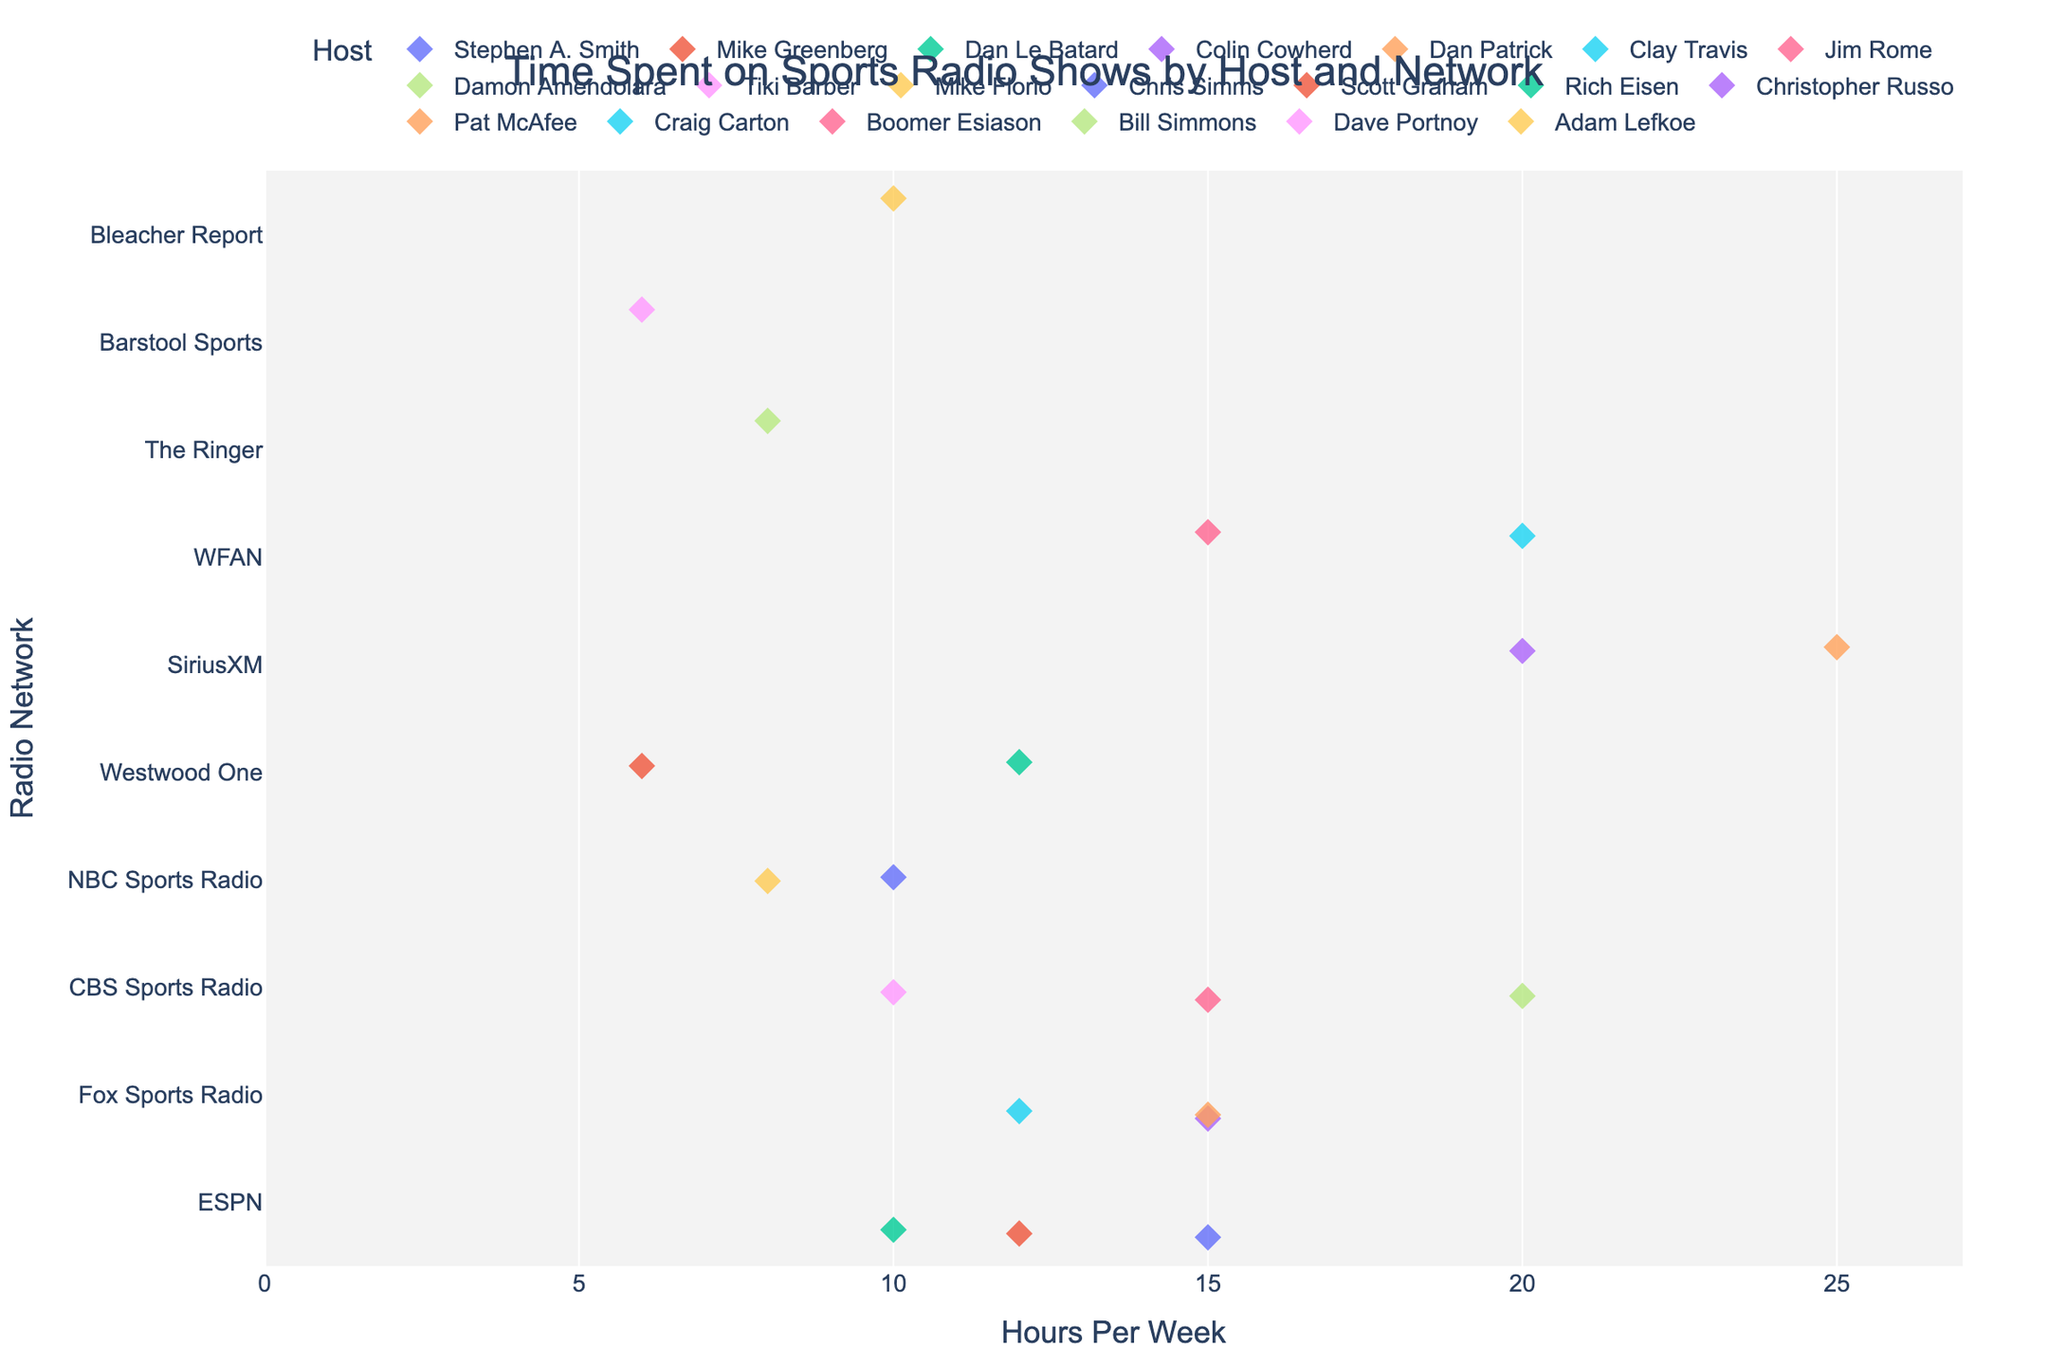What's the total number of hosts from ESPN? Look at the hosts listed under the ESPN network. There are three hosts: Stephen A. Smith, Mike Greenberg, and Dan Le Batard.
Answer: 3 Which hosts spend the most time on sports radio shows across all networks? Identify the hosts with the highest "Hours Per Week" values. Both Pat McAfee from SiriusXM and Damon Amendolara from CBS Sports Radio spend 25 hours each week, the highest among all hosts.
Answer: Pat McAfee, Damon Amendolara How many hours does Fox Sports Radio's Colin Cowherd spend compared to ESPN's Stephen A. Smith? Both Colin Cowherd and Stephen A. Smith spend 15 hours per week on their radio shows.
Answer: Equal What is the median duration of hosts' hours per week across all networks? List the "Hours Per Week" values in ascending order: 6, 6, 8, 8, 10, 10, 10, 10, 12, 12, 12, 15, 15, 15, 15, 15, 20, 20, 20, 25. The median is the middle value(s) in this ordered list. There are 20 data points, so the median is the average of the 10th and 11th values: (12 + 12) / 2 = 12.
Answer: 12 Which network has the greatest variability in hours spent by its hosts? Look at the range of "Hours Per Week" for each network. WFAN hosts have a range from 15 to 20 hours, whereas NBC hosts range from 8 to 10 hours. ESPN hosts range from 10 to 15 hours, and Fox Sports Radio hosts all spend between 12 and 15 hours. CBS Sports Radio has a range from 10 to 20 hours, suggesting highest variability. SiriusXM ranges from 20 to 25 hours. Barstool Sports and Westwood One have single values. CBS Sports Radio shows the greatest range.
Answer: CBS Sports Radio Which network has the highest average hours per week across its hosts? Calculate the average for each network. For instance, for Fox Sports Radio: (15+15+12)/3 = 14 hours. Repeat for all networks:
- ESPN: (15+12+10)/3 = 12.33
- Fox Sports Radio: 14
- CBS Sports Radio: (15+20+10)/3 = 15
- NBC Sports Radio: (8+10)/2 = 9
- Westwood One: (6+12)/2 = 9
- SiriusXM: (20+25)/2 = 22.5
- WFAN: (20+15)/2 = 17.5
- The Ringer: 8
- Barstool Sports: 6
- Bleacher Report: 10
SiriusXM has the highest average.
Answer: SiriusXM Between CBS Sports Radio and WFAN, which network has hosts spending a total of 55 hours per week? Calculate the total hours:
- CBS Sports Radio total = 15 + 20 + 10 = 45
- WFAN total = 20 + 15 = 35
Neither has a total of 55 hours per week.
Answer: Neither What's the average duration of the radio shows hosted by NBC Sports Radio hosts? Sum up the hours per week for NBC Sports Radio hosts and divide by the number of hosts: (8 + 10) / 2 = 9 hours.
Answer: 9 Considering Colin Cowherd and Stephen A. Smith both spend 15 hours per week on their shows, how does their weekly time compare to the average weekly time spent by all hosts? Calculate the overall average: 
(15 + 12 + 10 + 15 + 15 + 12 + 15 + 20 + 10 + 8 + 10 + 6 + 12 + 20 + 25 + 20 + 15 + 8 + 6 + 10) / 20 = 325 / 20 = 16.25 hours.
Both hosts spend 15 hours weekly, which is slightly below the overall average.
Answer: Below Who spends more time on air: Pat McAfee from SiriusXM or Mike Florio from NBC Sports Radio? Compare the hours per week: Pat McAfee spends 25 hours, and Mike Florio spends 8 hours. Pat McAfee spends more time.
Answer: Pat McAfee 